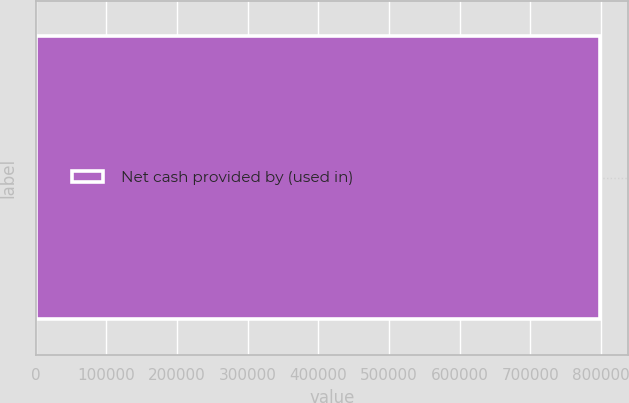<chart> <loc_0><loc_0><loc_500><loc_500><bar_chart><fcel>Net cash provided by (used in)<nl><fcel>798305<nl></chart> 